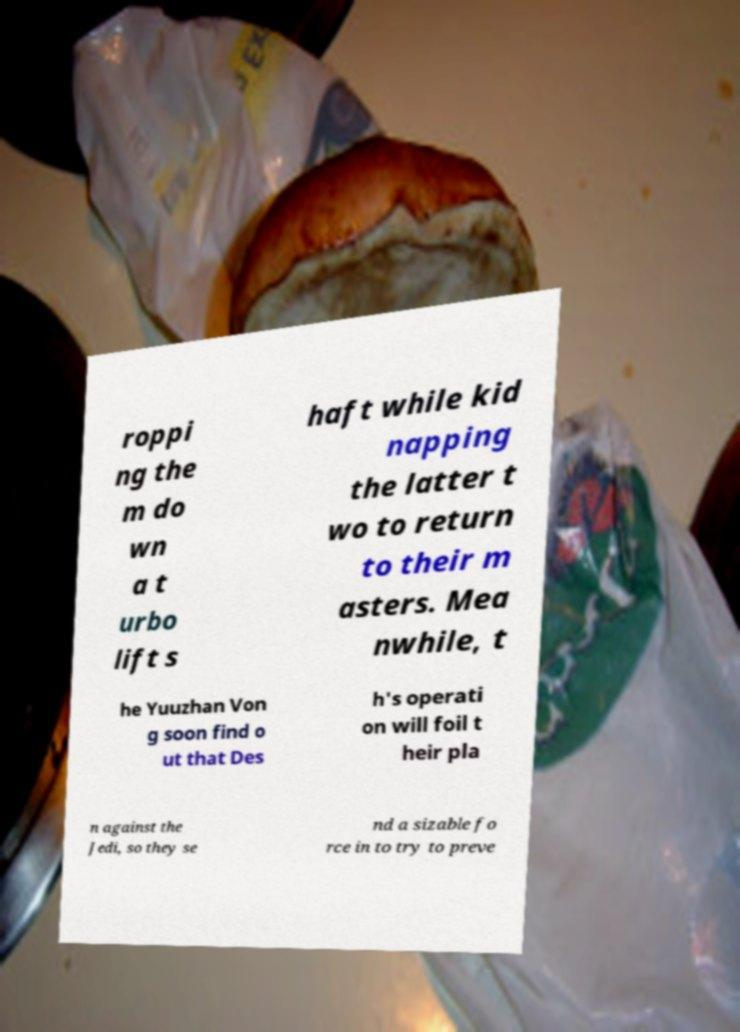Can you accurately transcribe the text from the provided image for me? roppi ng the m do wn a t urbo lift s haft while kid napping the latter t wo to return to their m asters. Mea nwhile, t he Yuuzhan Von g soon find o ut that Des h's operati on will foil t heir pla n against the Jedi, so they se nd a sizable fo rce in to try to preve 